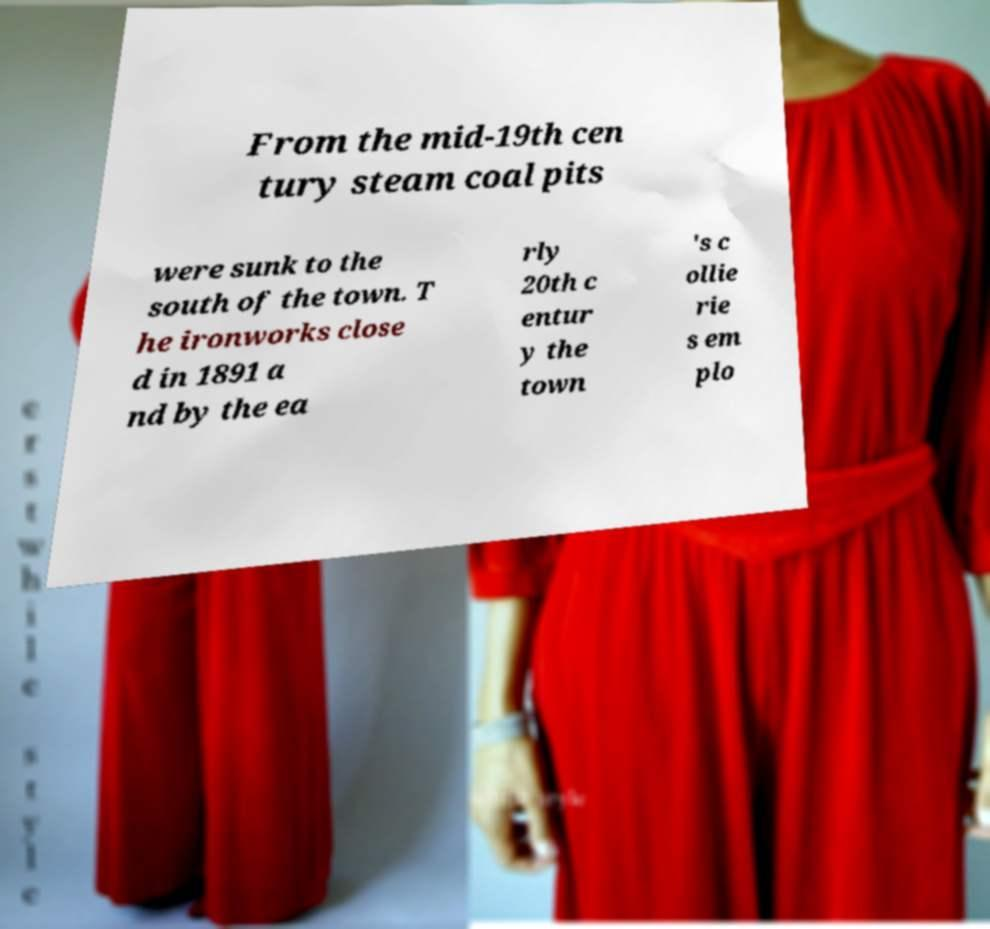What messages or text are displayed in this image? I need them in a readable, typed format. From the mid-19th cen tury steam coal pits were sunk to the south of the town. T he ironworks close d in 1891 a nd by the ea rly 20th c entur y the town 's c ollie rie s em plo 